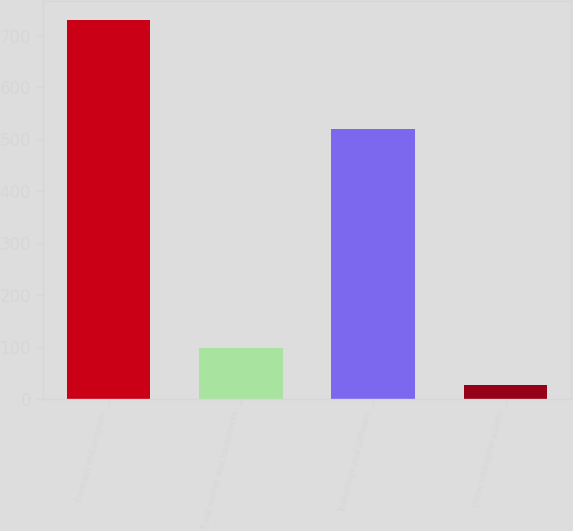Convert chart to OTSL. <chart><loc_0><loc_0><loc_500><loc_500><bar_chart><fcel>Contract and program<fcel>Trade names and trademarks<fcel>Technology and software<fcel>Other intangible assets<nl><fcel>730<fcel>97.3<fcel>520<fcel>27<nl></chart> 